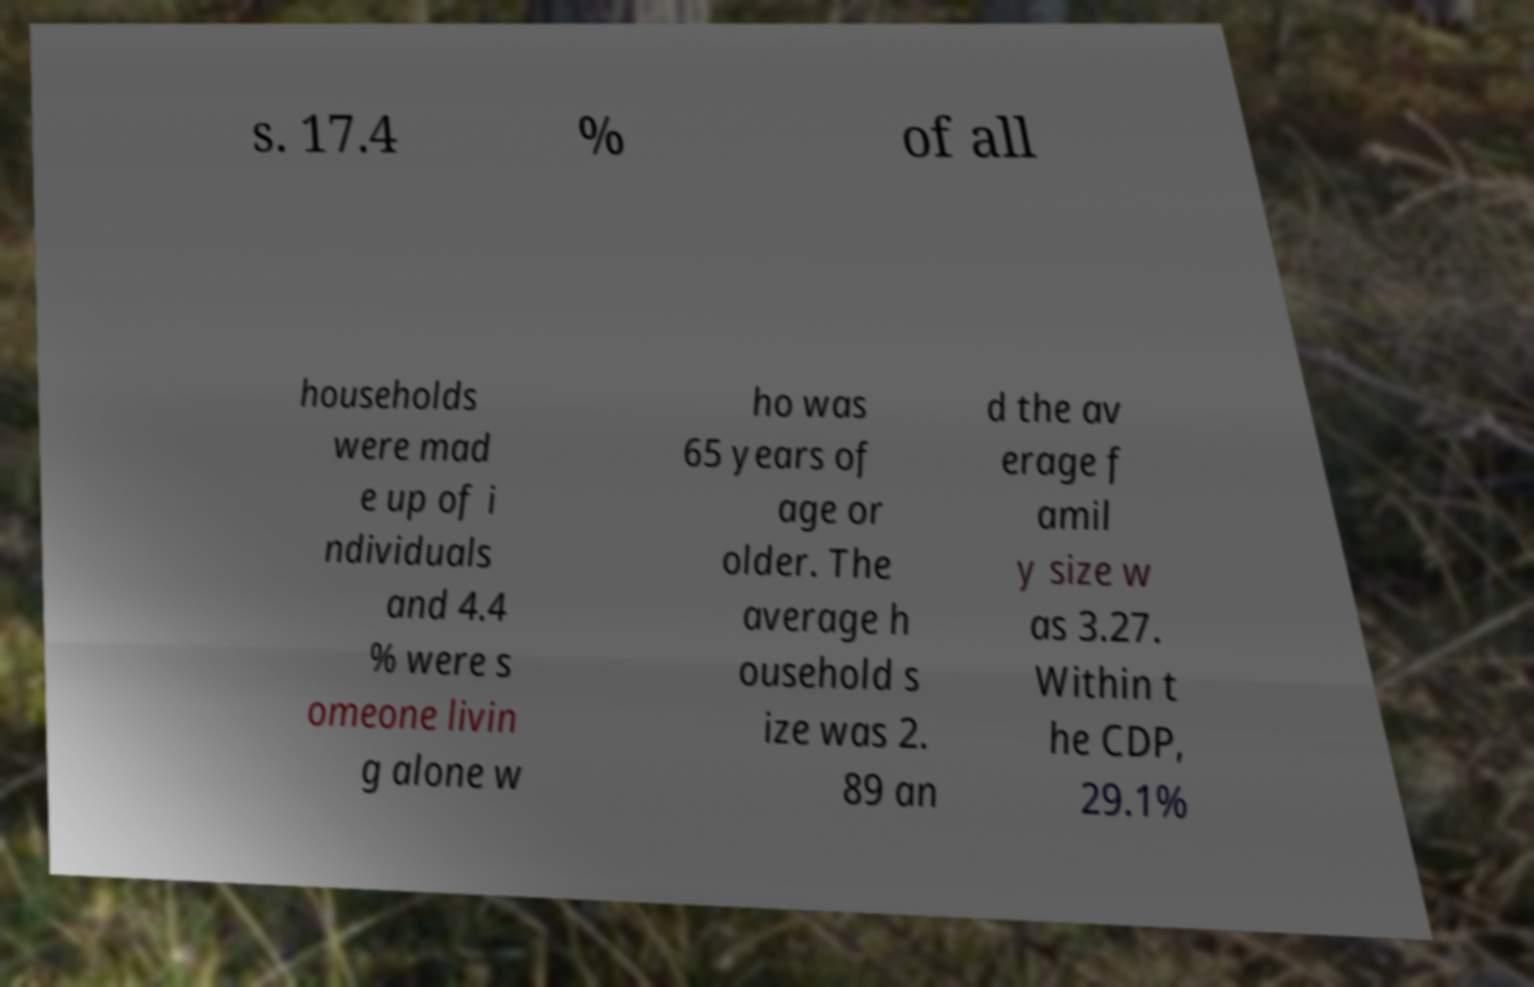Can you read and provide the text displayed in the image?This photo seems to have some interesting text. Can you extract and type it out for me? s. 17.4 % of all households were mad e up of i ndividuals and 4.4 % were s omeone livin g alone w ho was 65 years of age or older. The average h ousehold s ize was 2. 89 an d the av erage f amil y size w as 3.27. Within t he CDP, 29.1% 